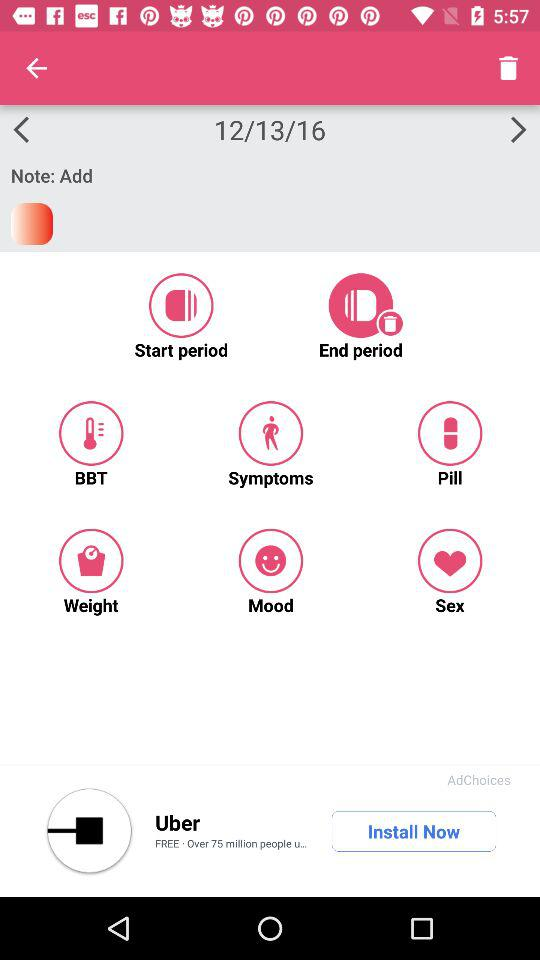What is the date? The date is December 13, 2016. 